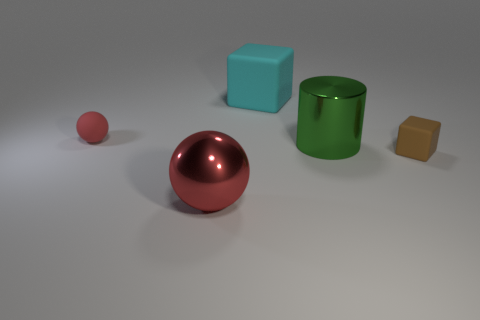Subtract all cyan blocks. How many blocks are left? 1 Subtract 1 cubes. How many cubes are left? 1 Add 5 matte spheres. How many objects exist? 10 Subtract all blocks. How many objects are left? 3 Add 3 purple rubber cubes. How many purple rubber cubes exist? 3 Subtract 1 cyan blocks. How many objects are left? 4 Subtract all cyan cylinders. Subtract all gray cubes. How many cylinders are left? 1 Subtract all green cylinders. How many purple blocks are left? 0 Subtract all yellow cylinders. Subtract all brown rubber blocks. How many objects are left? 4 Add 1 red matte spheres. How many red matte spheres are left? 2 